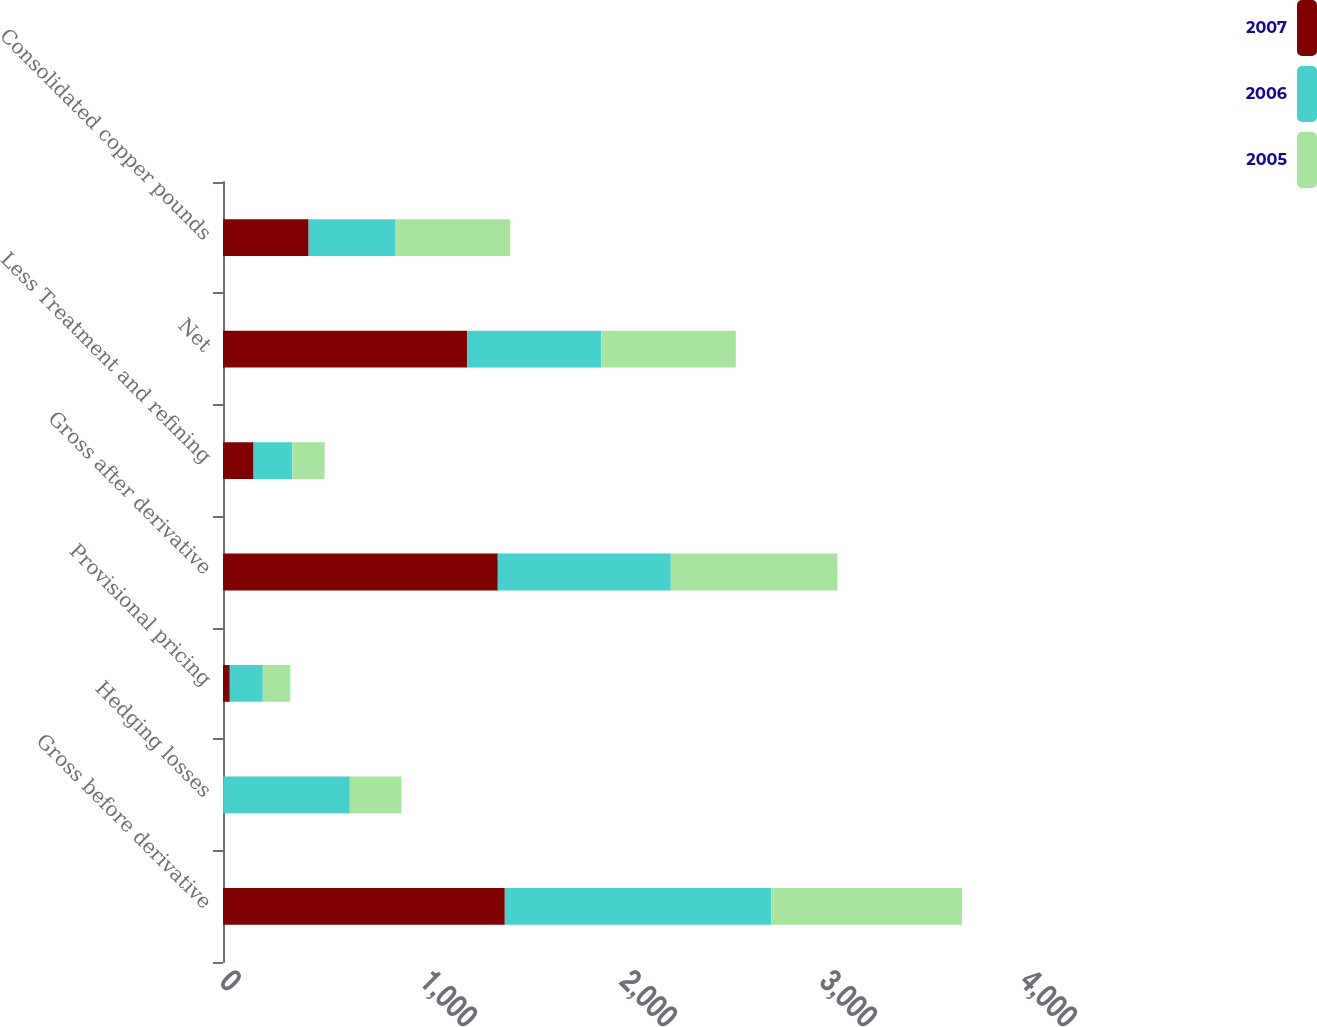<chart> <loc_0><loc_0><loc_500><loc_500><stacked_bar_chart><ecel><fcel>Gross before derivative<fcel>Hedging losses<fcel>Provisional pricing<fcel>Gross after derivative<fcel>Less Treatment and refining<fcel>Net<fcel>Consolidated copper pounds<nl><fcel>2007<fcel>1409<fcel>1<fcel>34<fcel>1374<fcel>153<fcel>1221<fcel>428<nl><fcel>2006<fcel>1333<fcel>633<fcel>165<fcel>865<fcel>194<fcel>671<fcel>435<nl><fcel>2005<fcel>953<fcel>258<fcel>138<fcel>833<fcel>161<fcel>672<fcel>573<nl></chart> 